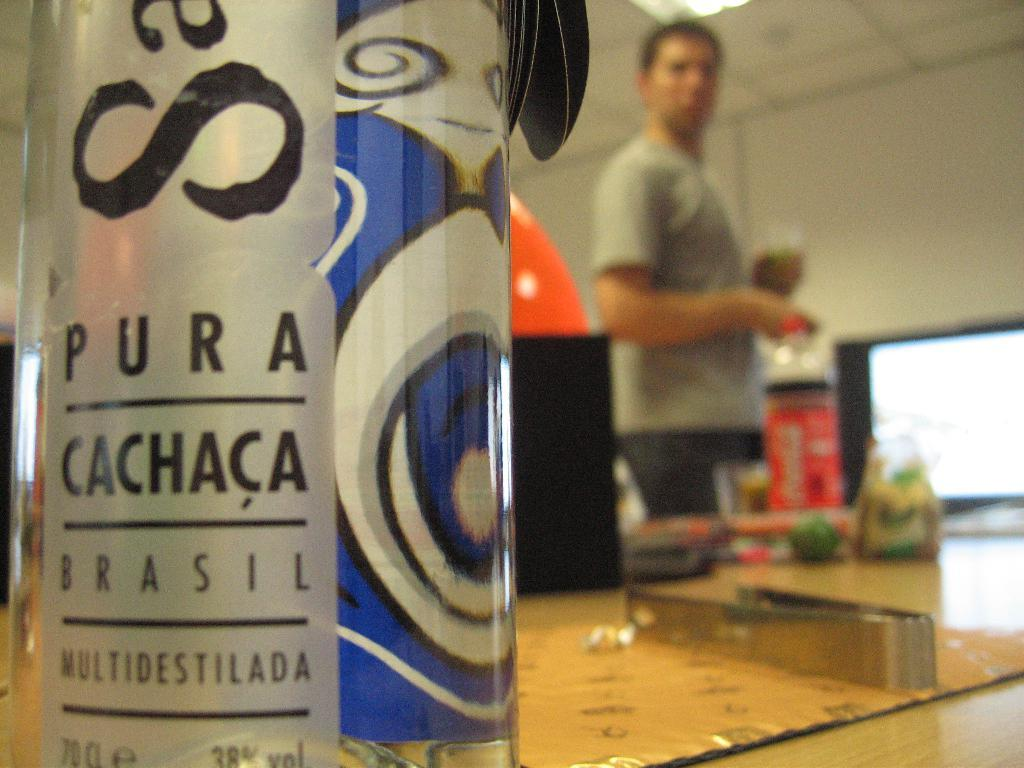<image>
Relay a brief, clear account of the picture shown. In focus, a water bottle with Pura Cachaca Brasil is shown with a blurred man standing behind it. 